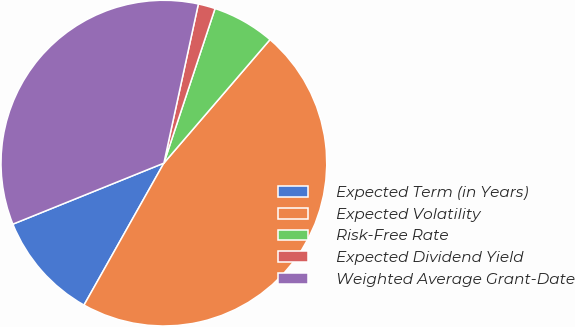Convert chart. <chart><loc_0><loc_0><loc_500><loc_500><pie_chart><fcel>Expected Term (in Years)<fcel>Expected Volatility<fcel>Risk-Free Rate<fcel>Expected Dividend Yield<fcel>Weighted Average Grant-Date<nl><fcel>10.73%<fcel>46.86%<fcel>6.21%<fcel>1.69%<fcel>34.51%<nl></chart> 